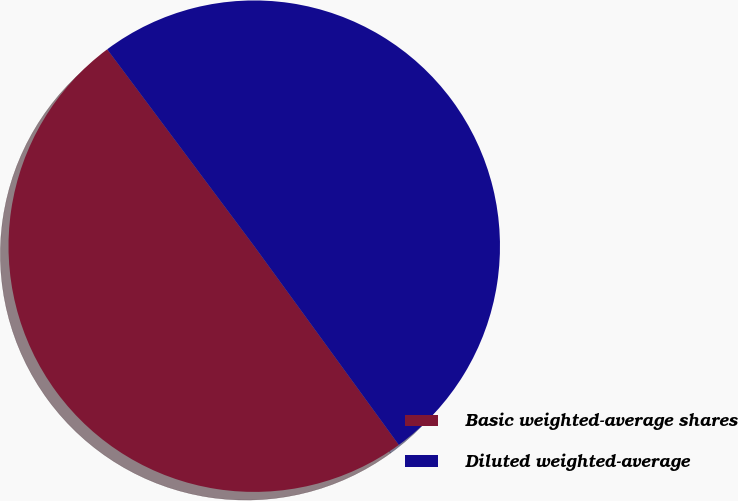Convert chart to OTSL. <chart><loc_0><loc_0><loc_500><loc_500><pie_chart><fcel>Basic weighted-average shares<fcel>Diluted weighted-average<nl><fcel>49.8%<fcel>50.2%<nl></chart> 